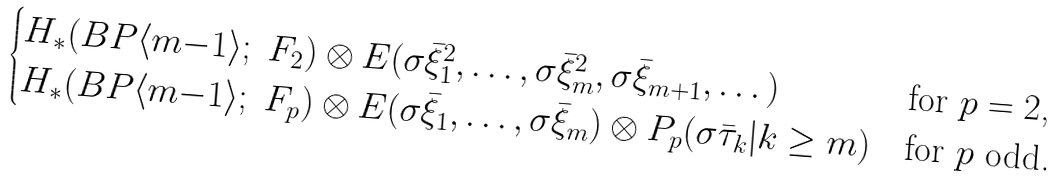<formula> <loc_0><loc_0><loc_500><loc_500>\begin{cases} H _ { * } ( B P \langle m { - } 1 \rangle ; \ F _ { 2 } ) \otimes E ( \sigma \bar { \xi } _ { 1 } ^ { 2 } , \dots , \sigma \bar { \xi } _ { m } ^ { 2 } , \sigma \bar { \xi } _ { m + 1 } , \dots ) & \text {for $p=2$,} \\ H _ { * } ( B P \langle m { - } 1 \rangle ; \ F _ { p } ) \otimes E ( \sigma \bar { \xi } _ { 1 } , \dots , \sigma \bar { \xi } _ { m } ) \otimes P _ { p } ( \sigma \bar { \tau } _ { k } | k \geq m ) & \text {for $p$ odd.} \end{cases}</formula> 